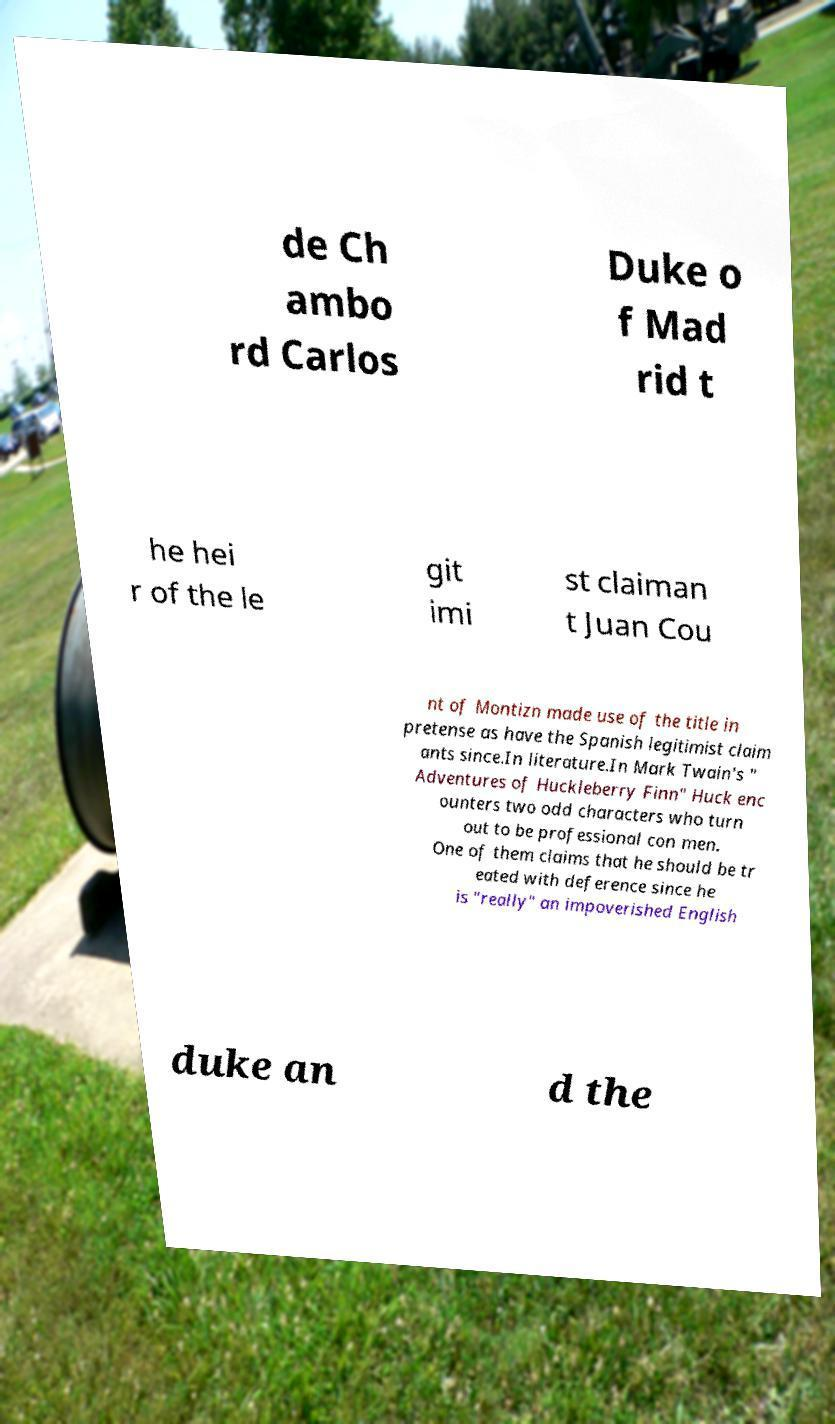There's text embedded in this image that I need extracted. Can you transcribe it verbatim? de Ch ambo rd Carlos Duke o f Mad rid t he hei r of the le git imi st claiman t Juan Cou nt of Montizn made use of the title in pretense as have the Spanish legitimist claim ants since.In literature.In Mark Twain's " Adventures of Huckleberry Finn" Huck enc ounters two odd characters who turn out to be professional con men. One of them claims that he should be tr eated with deference since he is "really" an impoverished English duke an d the 